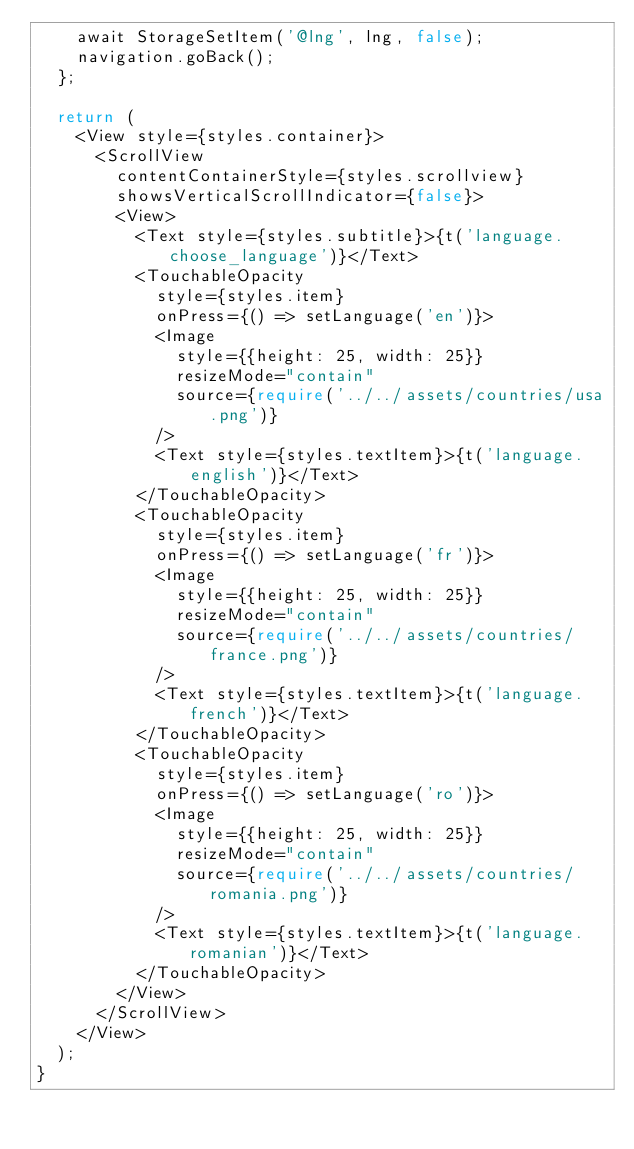<code> <loc_0><loc_0><loc_500><loc_500><_TypeScript_>    await StorageSetItem('@lng', lng, false);
    navigation.goBack();
  };

  return (
    <View style={styles.container}>
      <ScrollView
        contentContainerStyle={styles.scrollview}
        showsVerticalScrollIndicator={false}>
        <View>
          <Text style={styles.subtitle}>{t('language.choose_language')}</Text>
          <TouchableOpacity
            style={styles.item}
            onPress={() => setLanguage('en')}>
            <Image
              style={{height: 25, width: 25}}
              resizeMode="contain"
              source={require('../../assets/countries/usa.png')}
            />
            <Text style={styles.textItem}>{t('language.english')}</Text>
          </TouchableOpacity>
          <TouchableOpacity
            style={styles.item}
            onPress={() => setLanguage('fr')}>
            <Image
              style={{height: 25, width: 25}}
              resizeMode="contain"
              source={require('../../assets/countries/france.png')}
            />
            <Text style={styles.textItem}>{t('language.french')}</Text>
          </TouchableOpacity>
          <TouchableOpacity
            style={styles.item}
            onPress={() => setLanguage('ro')}>
            <Image
              style={{height: 25, width: 25}}
              resizeMode="contain"
              source={require('../../assets/countries/romania.png')}
            />
            <Text style={styles.textItem}>{t('language.romanian')}</Text>
          </TouchableOpacity>
        </View>
      </ScrollView>
    </View>
  );
}
</code> 